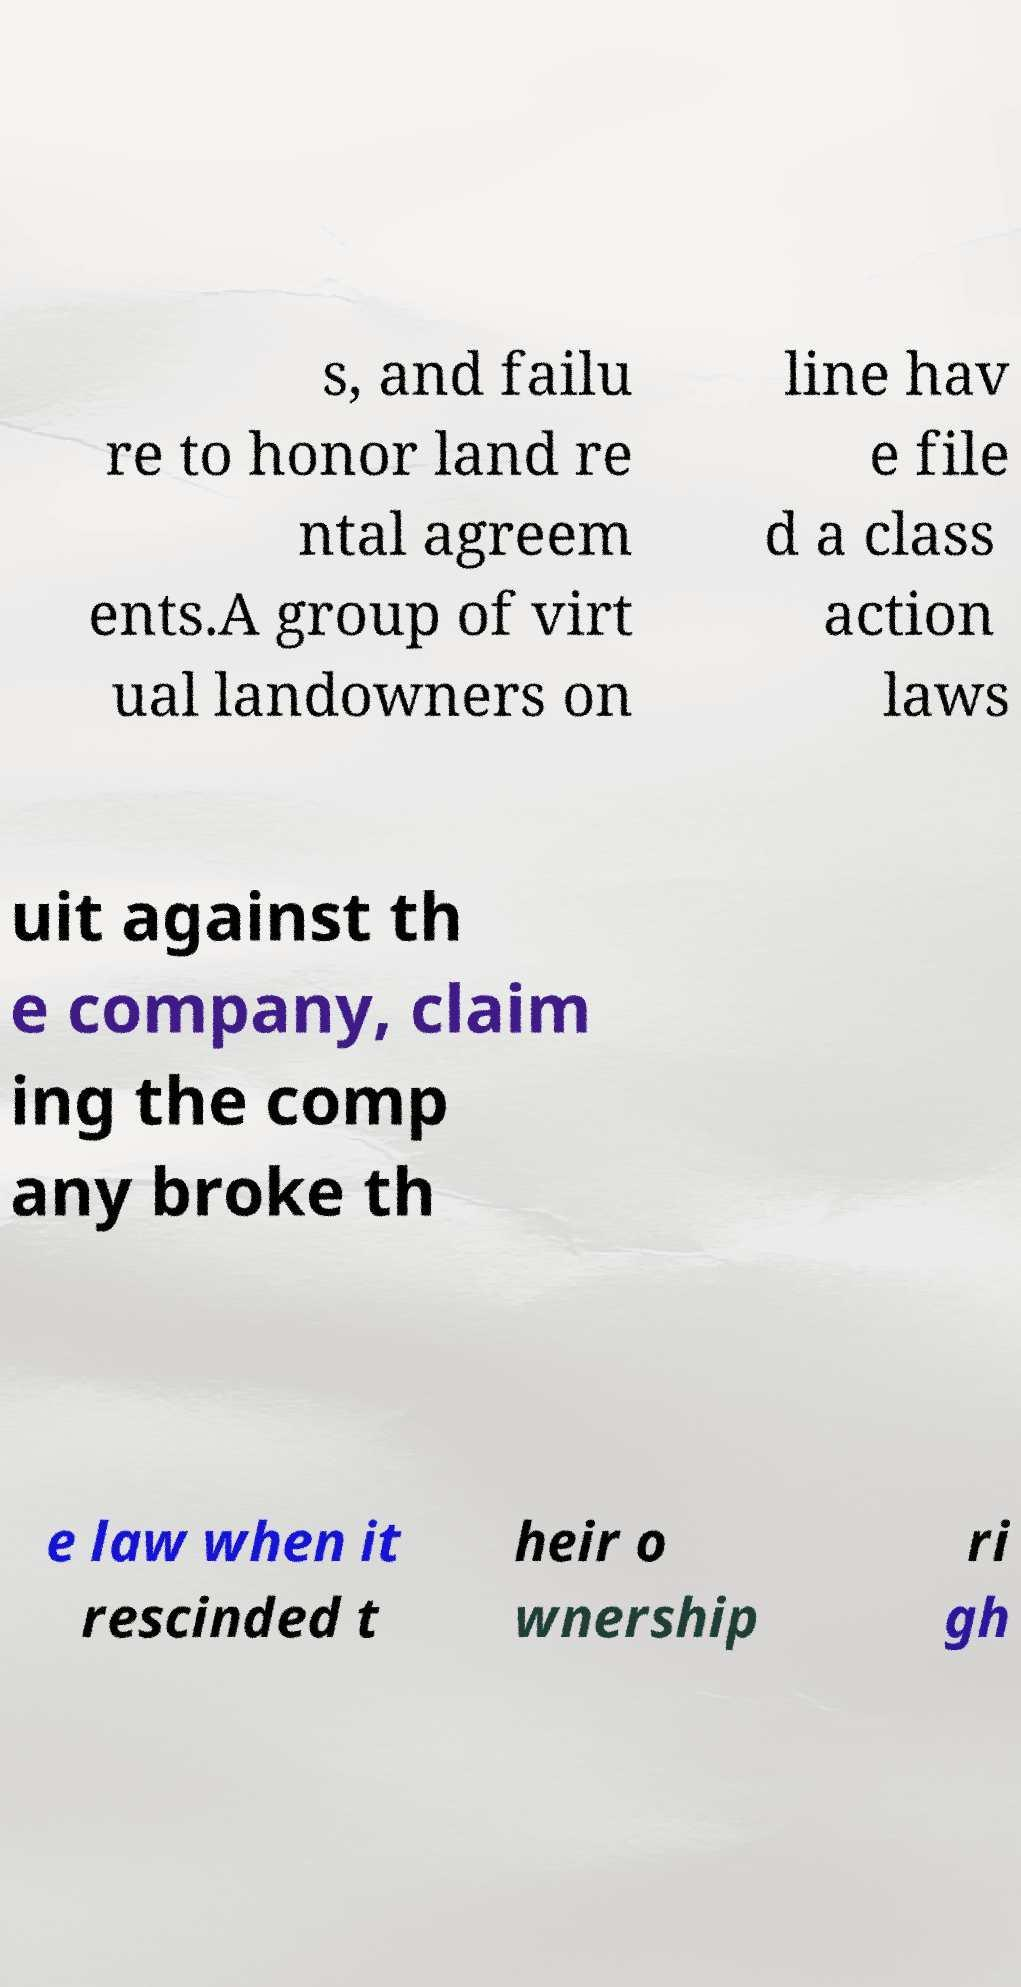There's text embedded in this image that I need extracted. Can you transcribe it verbatim? s, and failu re to honor land re ntal agreem ents.A group of virt ual landowners on line hav e file d a class action laws uit against th e company, claim ing the comp any broke th e law when it rescinded t heir o wnership ri gh 